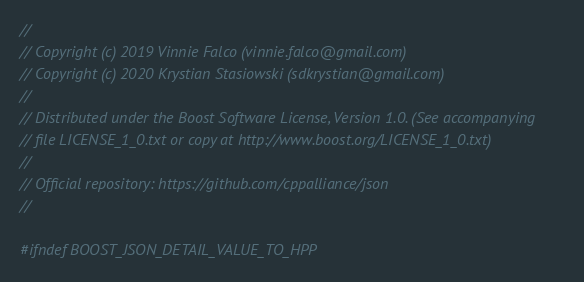<code> <loc_0><loc_0><loc_500><loc_500><_C++_>//
// Copyright (c) 2019 Vinnie Falco (vinnie.falco@gmail.com)
// Copyright (c) 2020 Krystian Stasiowski (sdkrystian@gmail.com)
//
// Distributed under the Boost Software License, Version 1.0. (See accompanying
// file LICENSE_1_0.txt or copy at http://www.boost.org/LICENSE_1_0.txt)
//
// Official repository: https://github.com/cppalliance/json
//

#ifndef BOOST_JSON_DETAIL_VALUE_TO_HPP</code> 